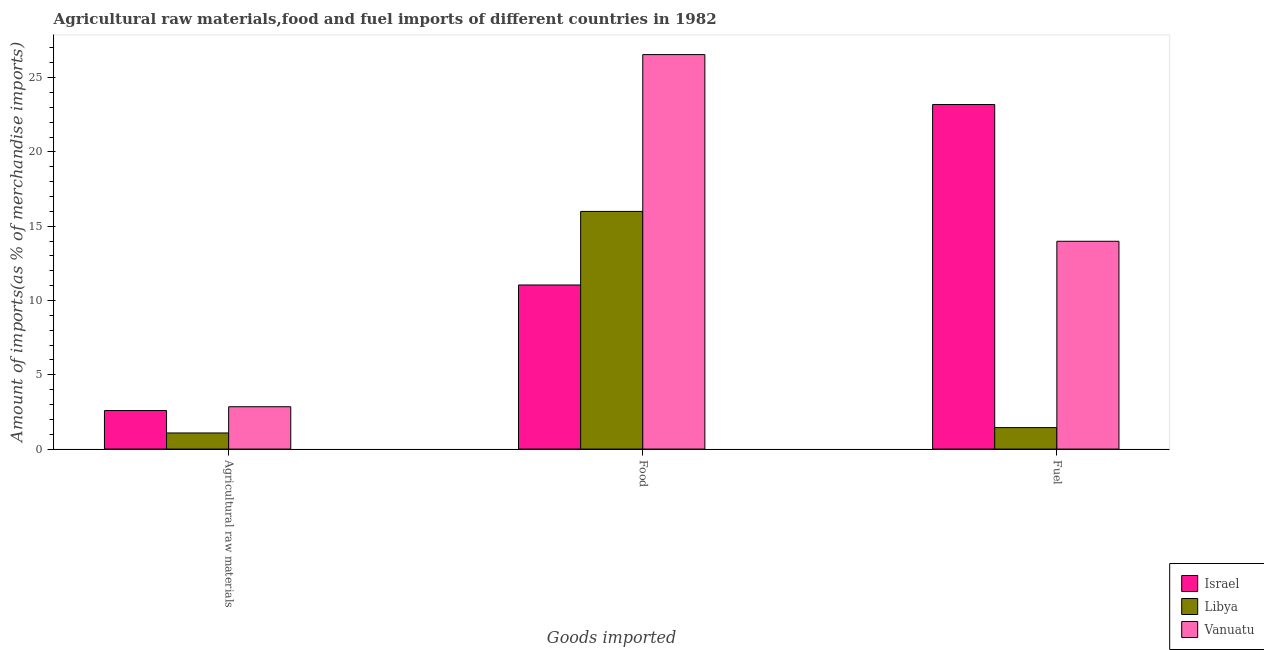How many bars are there on the 3rd tick from the right?
Your answer should be very brief. 3. What is the label of the 1st group of bars from the left?
Give a very brief answer. Agricultural raw materials. What is the percentage of raw materials imports in Vanuatu?
Make the answer very short. 2.85. Across all countries, what is the maximum percentage of raw materials imports?
Provide a succinct answer. 2.85. Across all countries, what is the minimum percentage of fuel imports?
Make the answer very short. 1.45. In which country was the percentage of food imports minimum?
Your response must be concise. Israel. What is the total percentage of fuel imports in the graph?
Your answer should be very brief. 38.61. What is the difference between the percentage of food imports in Vanuatu and that in Libya?
Your response must be concise. 10.55. What is the difference between the percentage of food imports in Vanuatu and the percentage of fuel imports in Libya?
Give a very brief answer. 25.1. What is the average percentage of raw materials imports per country?
Provide a short and direct response. 2.18. What is the difference between the percentage of food imports and percentage of fuel imports in Libya?
Offer a terse response. 14.55. What is the ratio of the percentage of food imports in Libya to that in Israel?
Provide a succinct answer. 1.45. What is the difference between the highest and the second highest percentage of fuel imports?
Provide a short and direct response. 9.2. What is the difference between the highest and the lowest percentage of fuel imports?
Make the answer very short. 21.74. Is the sum of the percentage of fuel imports in Vanuatu and Libya greater than the maximum percentage of raw materials imports across all countries?
Your answer should be very brief. Yes. What does the 2nd bar from the left in Fuel represents?
Make the answer very short. Libya. What does the 1st bar from the right in Fuel represents?
Provide a short and direct response. Vanuatu. Is it the case that in every country, the sum of the percentage of raw materials imports and percentage of food imports is greater than the percentage of fuel imports?
Your answer should be very brief. No. How many bars are there?
Offer a very short reply. 9. Are all the bars in the graph horizontal?
Make the answer very short. No. How many countries are there in the graph?
Keep it short and to the point. 3. Are the values on the major ticks of Y-axis written in scientific E-notation?
Ensure brevity in your answer.  No. How many legend labels are there?
Give a very brief answer. 3. What is the title of the graph?
Give a very brief answer. Agricultural raw materials,food and fuel imports of different countries in 1982. Does "Costa Rica" appear as one of the legend labels in the graph?
Your answer should be compact. No. What is the label or title of the X-axis?
Offer a terse response. Goods imported. What is the label or title of the Y-axis?
Provide a short and direct response. Amount of imports(as % of merchandise imports). What is the Amount of imports(as % of merchandise imports) of Israel in Agricultural raw materials?
Provide a short and direct response. 2.59. What is the Amount of imports(as % of merchandise imports) of Libya in Agricultural raw materials?
Your answer should be very brief. 1.08. What is the Amount of imports(as % of merchandise imports) of Vanuatu in Agricultural raw materials?
Ensure brevity in your answer.  2.85. What is the Amount of imports(as % of merchandise imports) of Israel in Food?
Your response must be concise. 11.04. What is the Amount of imports(as % of merchandise imports) in Libya in Food?
Offer a terse response. 15.99. What is the Amount of imports(as % of merchandise imports) of Vanuatu in Food?
Your answer should be compact. 26.55. What is the Amount of imports(as % of merchandise imports) of Israel in Fuel?
Your answer should be very brief. 23.19. What is the Amount of imports(as % of merchandise imports) in Libya in Fuel?
Keep it short and to the point. 1.45. What is the Amount of imports(as % of merchandise imports) of Vanuatu in Fuel?
Offer a very short reply. 13.98. Across all Goods imported, what is the maximum Amount of imports(as % of merchandise imports) in Israel?
Offer a terse response. 23.19. Across all Goods imported, what is the maximum Amount of imports(as % of merchandise imports) of Libya?
Provide a succinct answer. 15.99. Across all Goods imported, what is the maximum Amount of imports(as % of merchandise imports) in Vanuatu?
Provide a short and direct response. 26.55. Across all Goods imported, what is the minimum Amount of imports(as % of merchandise imports) in Israel?
Keep it short and to the point. 2.59. Across all Goods imported, what is the minimum Amount of imports(as % of merchandise imports) of Libya?
Offer a very short reply. 1.08. Across all Goods imported, what is the minimum Amount of imports(as % of merchandise imports) of Vanuatu?
Provide a succinct answer. 2.85. What is the total Amount of imports(as % of merchandise imports) of Israel in the graph?
Ensure brevity in your answer.  36.82. What is the total Amount of imports(as % of merchandise imports) in Libya in the graph?
Your response must be concise. 18.52. What is the total Amount of imports(as % of merchandise imports) of Vanuatu in the graph?
Your response must be concise. 43.38. What is the difference between the Amount of imports(as % of merchandise imports) of Israel in Agricultural raw materials and that in Food?
Provide a short and direct response. -8.45. What is the difference between the Amount of imports(as % of merchandise imports) of Libya in Agricultural raw materials and that in Food?
Provide a succinct answer. -14.91. What is the difference between the Amount of imports(as % of merchandise imports) of Vanuatu in Agricultural raw materials and that in Food?
Make the answer very short. -23.7. What is the difference between the Amount of imports(as % of merchandise imports) of Israel in Agricultural raw materials and that in Fuel?
Ensure brevity in your answer.  -20.59. What is the difference between the Amount of imports(as % of merchandise imports) in Libya in Agricultural raw materials and that in Fuel?
Make the answer very short. -0.36. What is the difference between the Amount of imports(as % of merchandise imports) of Vanuatu in Agricultural raw materials and that in Fuel?
Your answer should be very brief. -11.13. What is the difference between the Amount of imports(as % of merchandise imports) of Israel in Food and that in Fuel?
Provide a short and direct response. -12.14. What is the difference between the Amount of imports(as % of merchandise imports) in Libya in Food and that in Fuel?
Offer a very short reply. 14.55. What is the difference between the Amount of imports(as % of merchandise imports) in Vanuatu in Food and that in Fuel?
Provide a short and direct response. 12.56. What is the difference between the Amount of imports(as % of merchandise imports) of Israel in Agricultural raw materials and the Amount of imports(as % of merchandise imports) of Libya in Food?
Give a very brief answer. -13.4. What is the difference between the Amount of imports(as % of merchandise imports) of Israel in Agricultural raw materials and the Amount of imports(as % of merchandise imports) of Vanuatu in Food?
Your answer should be compact. -23.95. What is the difference between the Amount of imports(as % of merchandise imports) in Libya in Agricultural raw materials and the Amount of imports(as % of merchandise imports) in Vanuatu in Food?
Keep it short and to the point. -25.46. What is the difference between the Amount of imports(as % of merchandise imports) of Israel in Agricultural raw materials and the Amount of imports(as % of merchandise imports) of Libya in Fuel?
Provide a succinct answer. 1.15. What is the difference between the Amount of imports(as % of merchandise imports) of Israel in Agricultural raw materials and the Amount of imports(as % of merchandise imports) of Vanuatu in Fuel?
Give a very brief answer. -11.39. What is the difference between the Amount of imports(as % of merchandise imports) of Libya in Agricultural raw materials and the Amount of imports(as % of merchandise imports) of Vanuatu in Fuel?
Your answer should be compact. -12.9. What is the difference between the Amount of imports(as % of merchandise imports) in Israel in Food and the Amount of imports(as % of merchandise imports) in Libya in Fuel?
Ensure brevity in your answer.  9.6. What is the difference between the Amount of imports(as % of merchandise imports) in Israel in Food and the Amount of imports(as % of merchandise imports) in Vanuatu in Fuel?
Offer a very short reply. -2.94. What is the difference between the Amount of imports(as % of merchandise imports) of Libya in Food and the Amount of imports(as % of merchandise imports) of Vanuatu in Fuel?
Your response must be concise. 2.01. What is the average Amount of imports(as % of merchandise imports) in Israel per Goods imported?
Offer a very short reply. 12.27. What is the average Amount of imports(as % of merchandise imports) of Libya per Goods imported?
Offer a terse response. 6.17. What is the average Amount of imports(as % of merchandise imports) in Vanuatu per Goods imported?
Your answer should be very brief. 14.46. What is the difference between the Amount of imports(as % of merchandise imports) in Israel and Amount of imports(as % of merchandise imports) in Libya in Agricultural raw materials?
Offer a terse response. 1.51. What is the difference between the Amount of imports(as % of merchandise imports) of Israel and Amount of imports(as % of merchandise imports) of Vanuatu in Agricultural raw materials?
Make the answer very short. -0.26. What is the difference between the Amount of imports(as % of merchandise imports) in Libya and Amount of imports(as % of merchandise imports) in Vanuatu in Agricultural raw materials?
Your answer should be compact. -1.77. What is the difference between the Amount of imports(as % of merchandise imports) in Israel and Amount of imports(as % of merchandise imports) in Libya in Food?
Offer a very short reply. -4.95. What is the difference between the Amount of imports(as % of merchandise imports) in Israel and Amount of imports(as % of merchandise imports) in Vanuatu in Food?
Offer a terse response. -15.5. What is the difference between the Amount of imports(as % of merchandise imports) of Libya and Amount of imports(as % of merchandise imports) of Vanuatu in Food?
Offer a very short reply. -10.55. What is the difference between the Amount of imports(as % of merchandise imports) of Israel and Amount of imports(as % of merchandise imports) of Libya in Fuel?
Offer a very short reply. 21.74. What is the difference between the Amount of imports(as % of merchandise imports) in Israel and Amount of imports(as % of merchandise imports) in Vanuatu in Fuel?
Your answer should be very brief. 9.2. What is the difference between the Amount of imports(as % of merchandise imports) in Libya and Amount of imports(as % of merchandise imports) in Vanuatu in Fuel?
Offer a terse response. -12.54. What is the ratio of the Amount of imports(as % of merchandise imports) of Israel in Agricultural raw materials to that in Food?
Your response must be concise. 0.23. What is the ratio of the Amount of imports(as % of merchandise imports) in Libya in Agricultural raw materials to that in Food?
Give a very brief answer. 0.07. What is the ratio of the Amount of imports(as % of merchandise imports) of Vanuatu in Agricultural raw materials to that in Food?
Provide a succinct answer. 0.11. What is the ratio of the Amount of imports(as % of merchandise imports) of Israel in Agricultural raw materials to that in Fuel?
Your answer should be compact. 0.11. What is the ratio of the Amount of imports(as % of merchandise imports) in Libya in Agricultural raw materials to that in Fuel?
Provide a short and direct response. 0.75. What is the ratio of the Amount of imports(as % of merchandise imports) in Vanuatu in Agricultural raw materials to that in Fuel?
Provide a succinct answer. 0.2. What is the ratio of the Amount of imports(as % of merchandise imports) of Israel in Food to that in Fuel?
Ensure brevity in your answer.  0.48. What is the ratio of the Amount of imports(as % of merchandise imports) in Libya in Food to that in Fuel?
Keep it short and to the point. 11.06. What is the ratio of the Amount of imports(as % of merchandise imports) of Vanuatu in Food to that in Fuel?
Your answer should be very brief. 1.9. What is the difference between the highest and the second highest Amount of imports(as % of merchandise imports) of Israel?
Your answer should be compact. 12.14. What is the difference between the highest and the second highest Amount of imports(as % of merchandise imports) in Libya?
Provide a succinct answer. 14.55. What is the difference between the highest and the second highest Amount of imports(as % of merchandise imports) of Vanuatu?
Provide a short and direct response. 12.56. What is the difference between the highest and the lowest Amount of imports(as % of merchandise imports) of Israel?
Make the answer very short. 20.59. What is the difference between the highest and the lowest Amount of imports(as % of merchandise imports) in Libya?
Your answer should be compact. 14.91. What is the difference between the highest and the lowest Amount of imports(as % of merchandise imports) in Vanuatu?
Your response must be concise. 23.7. 